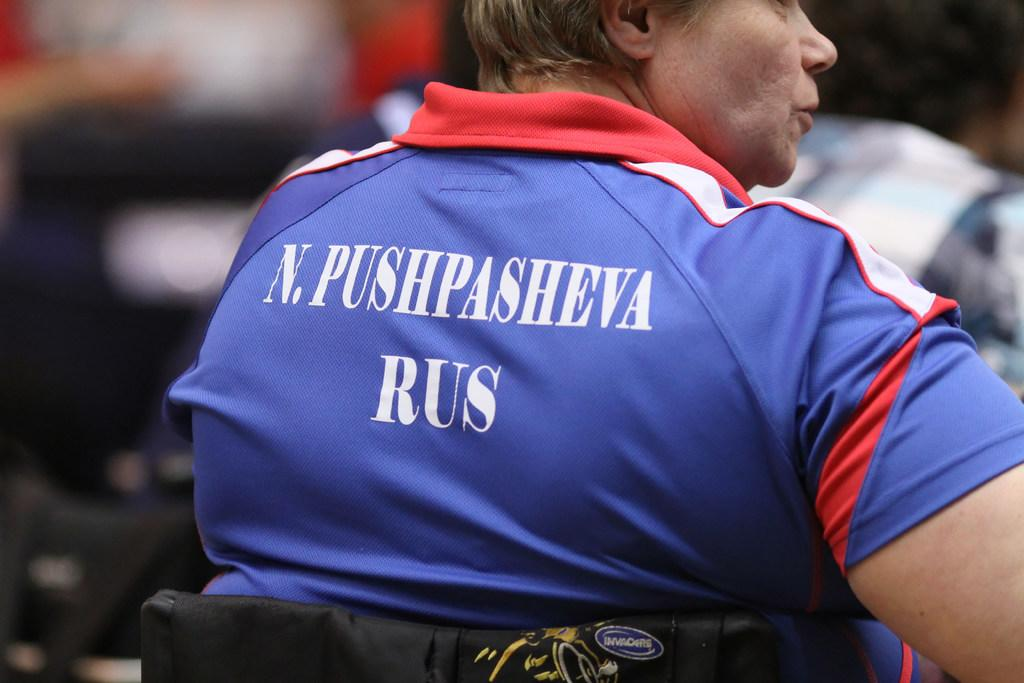Who is present in the image? There is a man in the image. What is the man wearing in the image? The man is wearing a t-shirt in the image. What can be seen on the t-shirt? The t-shirt has text on it. What type of key is used to unlock the system in the image? There is no system or key present in the image; it only features a man wearing a t-shirt with text on it. 